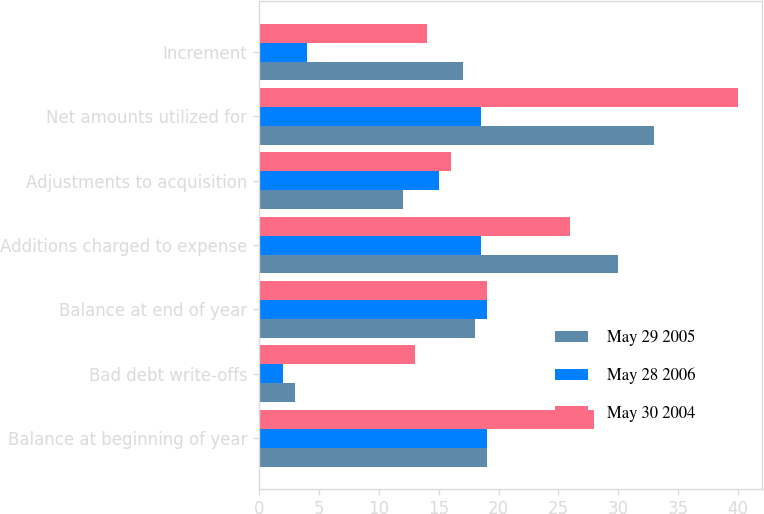Convert chart to OTSL. <chart><loc_0><loc_0><loc_500><loc_500><stacked_bar_chart><ecel><fcel>Balance at beginning of year<fcel>Bad debt write-offs<fcel>Balance at end of year<fcel>Additions charged to expense<fcel>Adjustments to acquisition<fcel>Net amounts utilized for<fcel>Increment<nl><fcel>May 29 2005<fcel>19<fcel>3<fcel>18<fcel>30<fcel>12<fcel>33<fcel>17<nl><fcel>May 28 2006<fcel>19<fcel>2<fcel>19<fcel>18.5<fcel>15<fcel>18.5<fcel>4<nl><fcel>May 30 2004<fcel>28<fcel>13<fcel>19<fcel>26<fcel>16<fcel>40<fcel>14<nl></chart> 